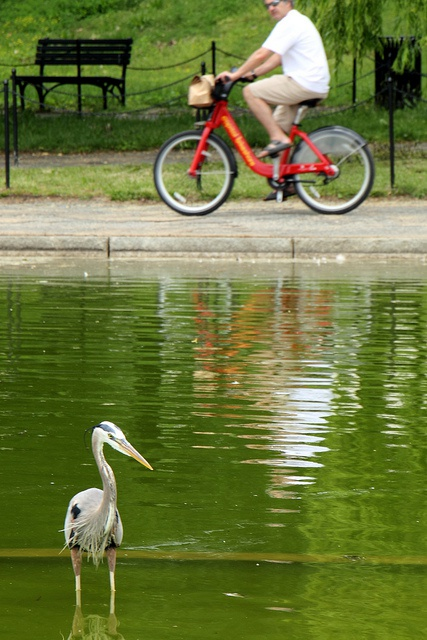Describe the objects in this image and their specific colors. I can see bicycle in darkgreen, olive, black, darkgray, and gray tones, people in darkgreen, white, tan, and darkgray tones, bird in darkgreen, darkgray, lightgray, and gray tones, and bench in darkgreen, black, and olive tones in this image. 